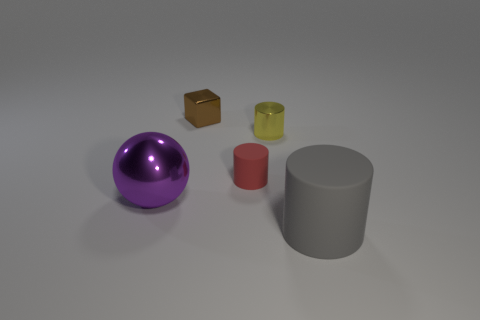Add 1 shiny objects. How many objects exist? 6 Subtract all cyan cylinders. Subtract all green balls. How many cylinders are left? 3 Subtract 1 yellow cylinders. How many objects are left? 4 Subtract all balls. How many objects are left? 4 Subtract all brown things. Subtract all small shiny cylinders. How many objects are left? 3 Add 2 tiny metal things. How many tiny metal things are left? 4 Add 1 small rubber things. How many small rubber things exist? 2 